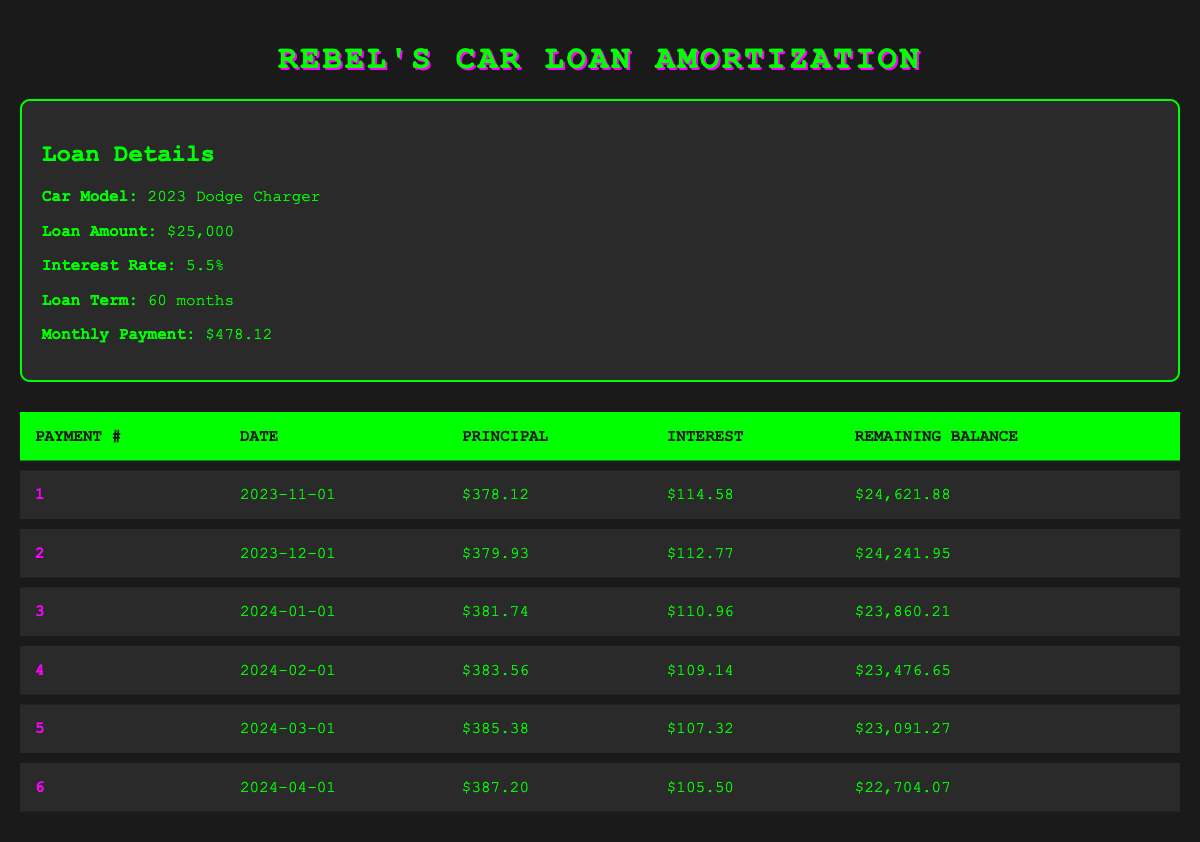What is the total loan amount for the car? The loan amount is explicitly stated in the loan details section of the table as $25,000.
Answer: 25,000 What is the monthly payment amount? The monthly payment is specified in the loan details section, which indicates a monthly payment of $478.12.
Answer: 478.12 How much was paid towards the principal in the first payment? The principal payment for the first payment is provided in the payment details, showing $378.12.
Answer: 378.12 What is the remaining balance after the second payment? The remaining balance after the second payment is listed in the payment details as $24,241.95.
Answer: 24,241.95 Is the interest payment for the third payment greater than $110? The interest payment for the third payment is $110.96, which is greater than $110.
Answer: Yes What is the total principal paid after the first three payments? To find the total principal paid after the first three payments, we sum the principal payments: 378.12 + 379.93 + 381.74 = 1,139.79.
Answer: 1,139.79 What is the average interest payment for the first four months? The interest payments for the first four months are $114.58, $112.77, $110.96, and $109.14. First, we sum these values: 114.58 + 112.77 + 110.96 + 109.14 = 447.45. Then divide by 4 (the number of months): 447.45 / 4 = 111.86.
Answer: 111.86 How much total payment goes towards interest after the first six payments? We sum the interest payments for the first six payments: 114.58 + 112.77 + 110.96 + 109.14 + 107.32 + 105.50 = 660.27.
Answer: 660.27 Does the remaining balance decrease with each payment? Observing the table, the remaining balance decreases with each payment, indicating it is valid to say yes.
Answer: Yes 